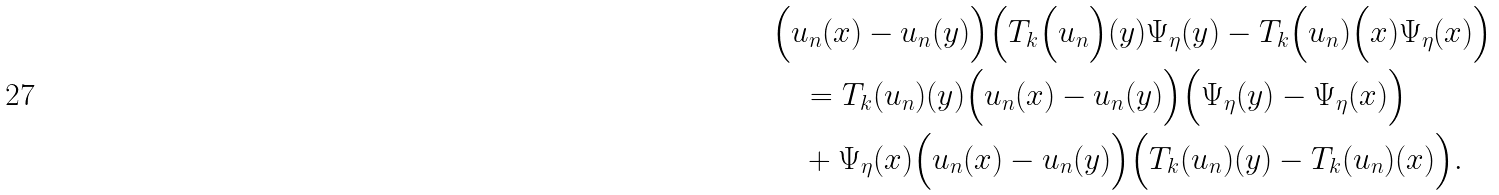<formula> <loc_0><loc_0><loc_500><loc_500>& \Big ( u _ { n } ( x ) - u _ { n } ( y ) \Big ) \Big ( T _ { k } \Big ( u _ { n } \Big ) ( y ) \Psi _ { \eta } ( y ) - T _ { k } \Big ( u _ { n } ) \Big ( x ) \Psi _ { \eta } ( x ) \Big ) \\ & \quad = T _ { k } ( u _ { n } ) ( y ) \Big ( u _ { n } ( x ) - u _ { n } ( y ) \Big ) \Big ( \Psi _ { \eta } ( y ) - \Psi _ { \eta } ( x ) \Big ) \\ & \quad + \Psi _ { \eta } ( x ) \Big ( u _ { n } ( x ) - u _ { n } ( y ) \Big ) \Big ( T _ { k } ( u _ { n } ) ( y ) - T _ { k } ( u _ { n } ) ( x ) \Big ) .</formula> 